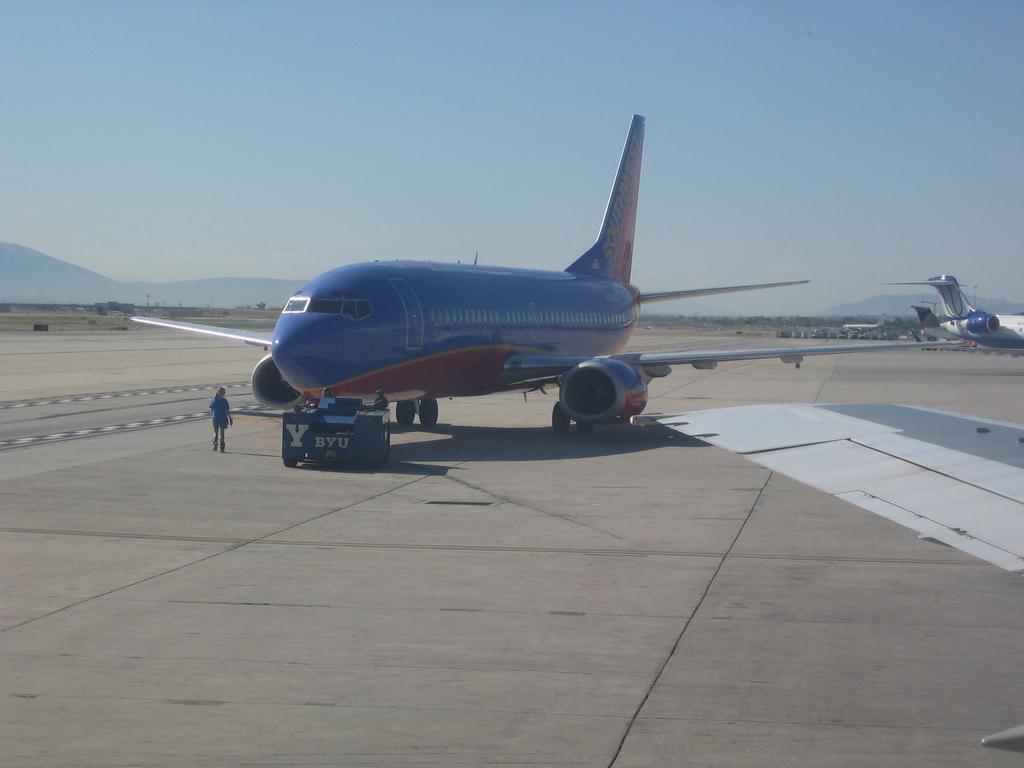Can you describe this image briefly? In this picture we can see airplanes on the ground, here we can see people and some objects in the background we can see mountains, sky. 